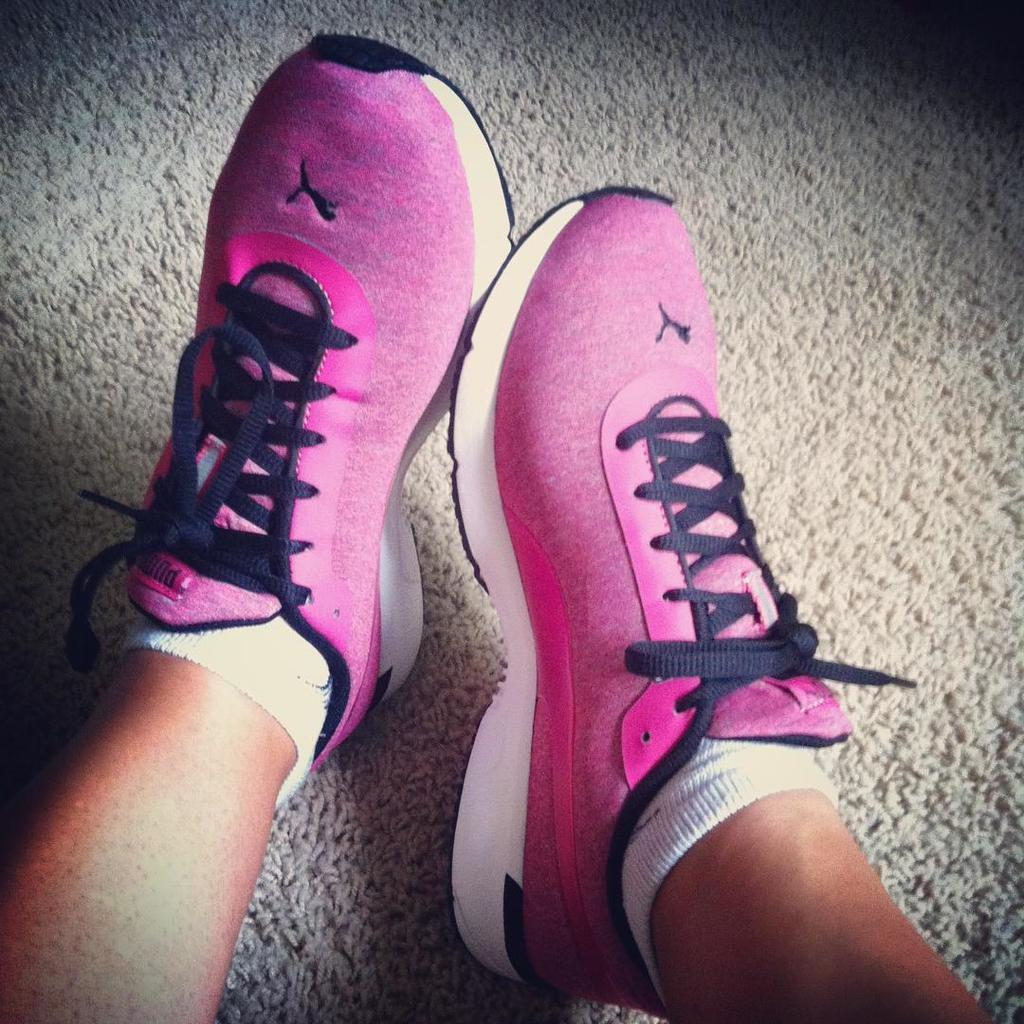What body parts are visible in the image? There are persons' legs visible in the image. What are the persons' legs wearing? The persons' legs are wearing footwear. On what surface are the legs placed? The legs are on a surface. How many boys are riding the goat in the image? There are no boys or goats present in the image; only persons' legs and footwear are visible. 